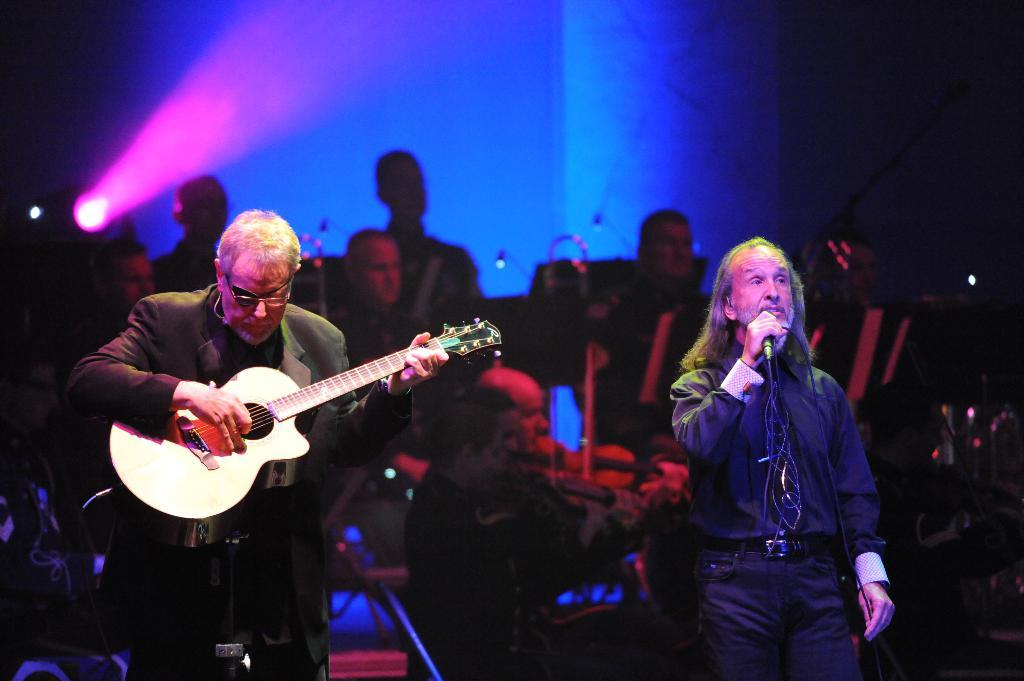What is happening in the image involving a group of people? The people in the image are performing with musical instruments. Can you describe the specific roles of some of the individuals in the group? One person is playing a guitar, and another person is singing with the help of a microphone. What type of flesh is being served to the audience in the image? There is no flesh being served in the image; the group of people is performing with musical instruments. 